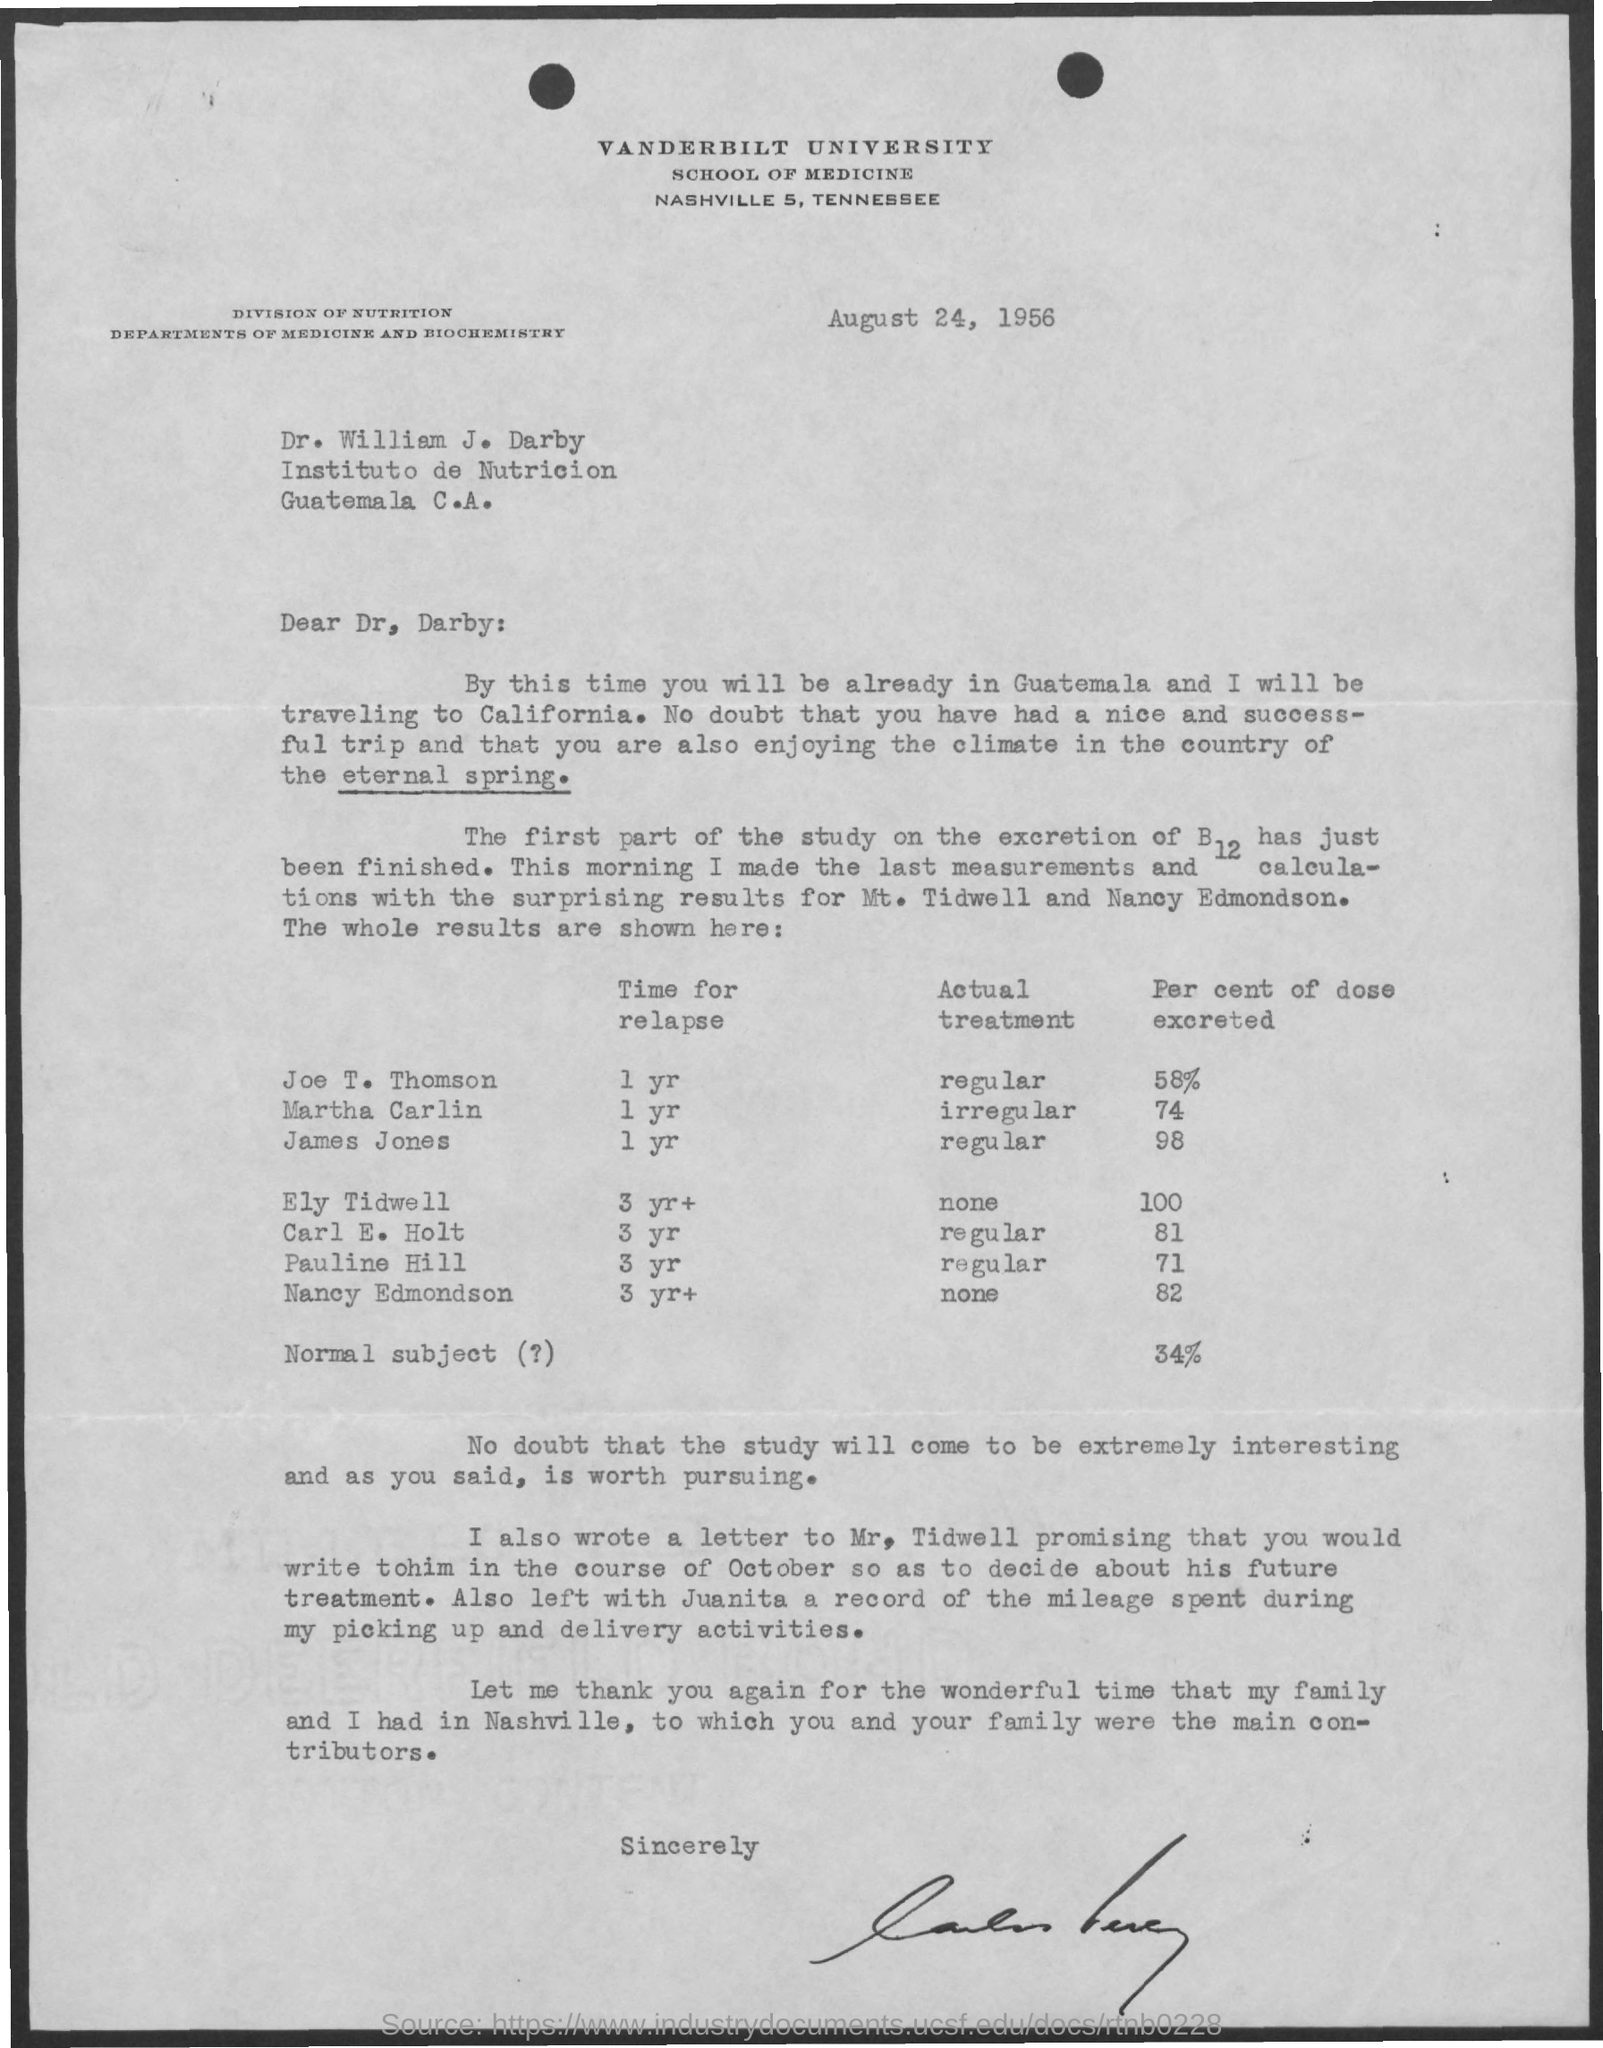Give some essential details in this illustration. Martha Carlin excreted 74% of the B12 dose in her body according to the study. According to the study, James Jones excreted 98% of the B12 dose that he received. The letter head mentioned Vanderbilt University. The issued date of this letter is August 24, 1956. What is the predicted time for relapse calculated to be for Joe T. Thomson at one year? 